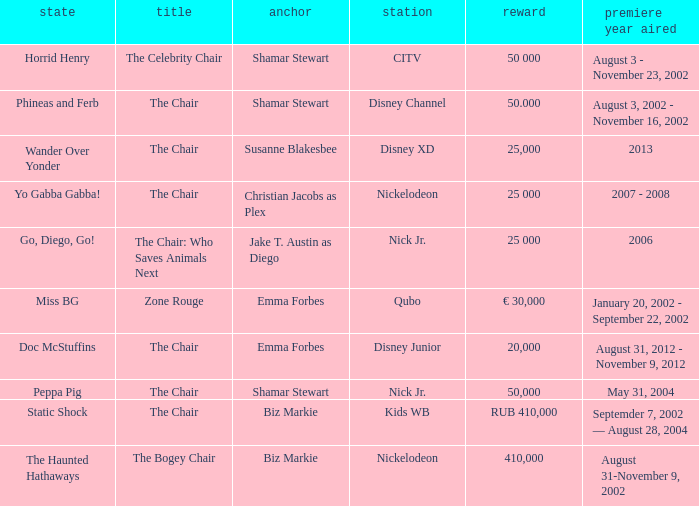What year did Zone Rouge first air? January 20, 2002 - September 22, 2002. 